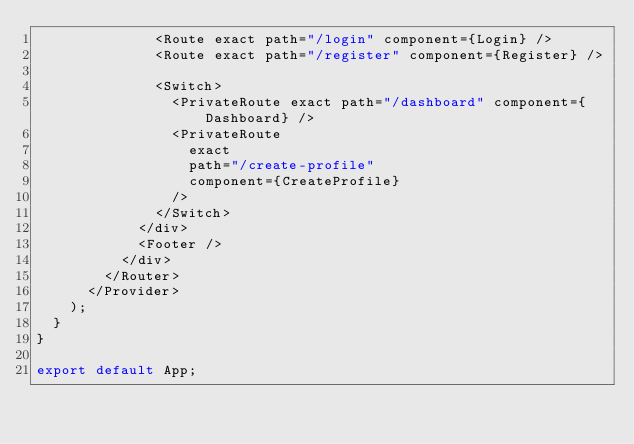<code> <loc_0><loc_0><loc_500><loc_500><_JavaScript_>              <Route exact path="/login" component={Login} />
              <Route exact path="/register" component={Register} />

              <Switch>
                <PrivateRoute exact path="/dashboard" component={Dashboard} />
                <PrivateRoute
                  exact
                  path="/create-profile"
                  component={CreateProfile}
                />
              </Switch>
            </div>
            <Footer />
          </div>
        </Router>
      </Provider>
    );
  }
}

export default App;
</code> 